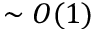<formula> <loc_0><loc_0><loc_500><loc_500>\sim O ( 1 )</formula> 